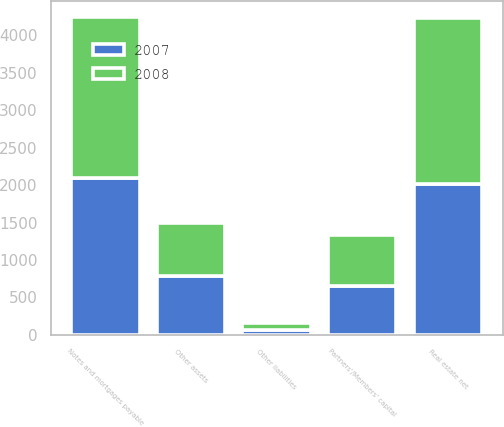<chart> <loc_0><loc_0><loc_500><loc_500><stacked_bar_chart><ecel><fcel>Real estate net<fcel>Other assets<fcel>Notes and mortgages payable<fcel>Other liabilities<fcel>Partners'/Members' capital<nl><fcel>2007<fcel>2012.3<fcel>791.3<fcel>2089.3<fcel>65.3<fcel>649<nl><fcel>2008<fcel>2223.3<fcel>701.3<fcel>2157.7<fcel>86.2<fcel>680.7<nl></chart> 